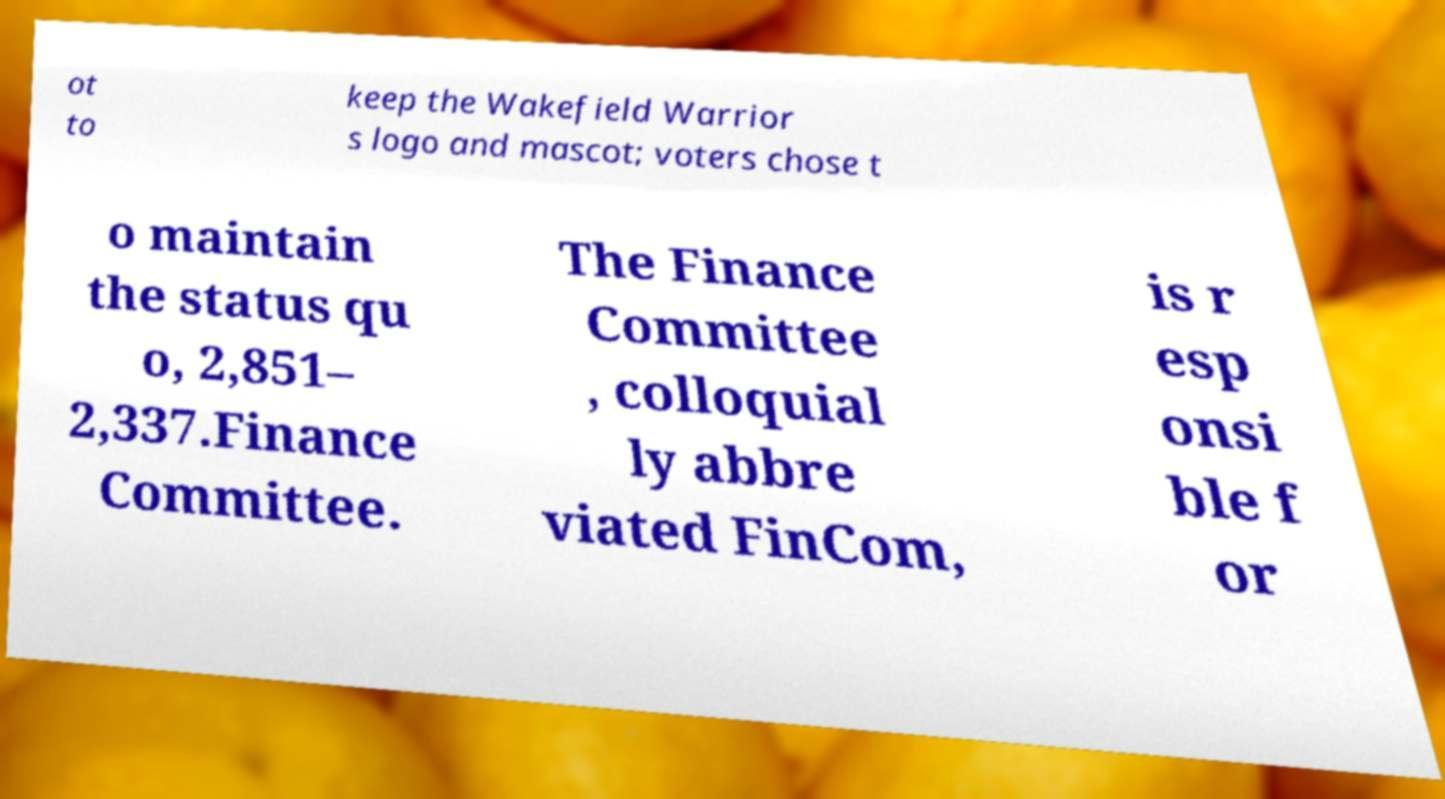Please read and relay the text visible in this image. What does it say? ot to keep the Wakefield Warrior s logo and mascot; voters chose t o maintain the status qu o, 2,851– 2,337.Finance Committee. The Finance Committee , colloquial ly abbre viated FinCom, is r esp onsi ble f or 